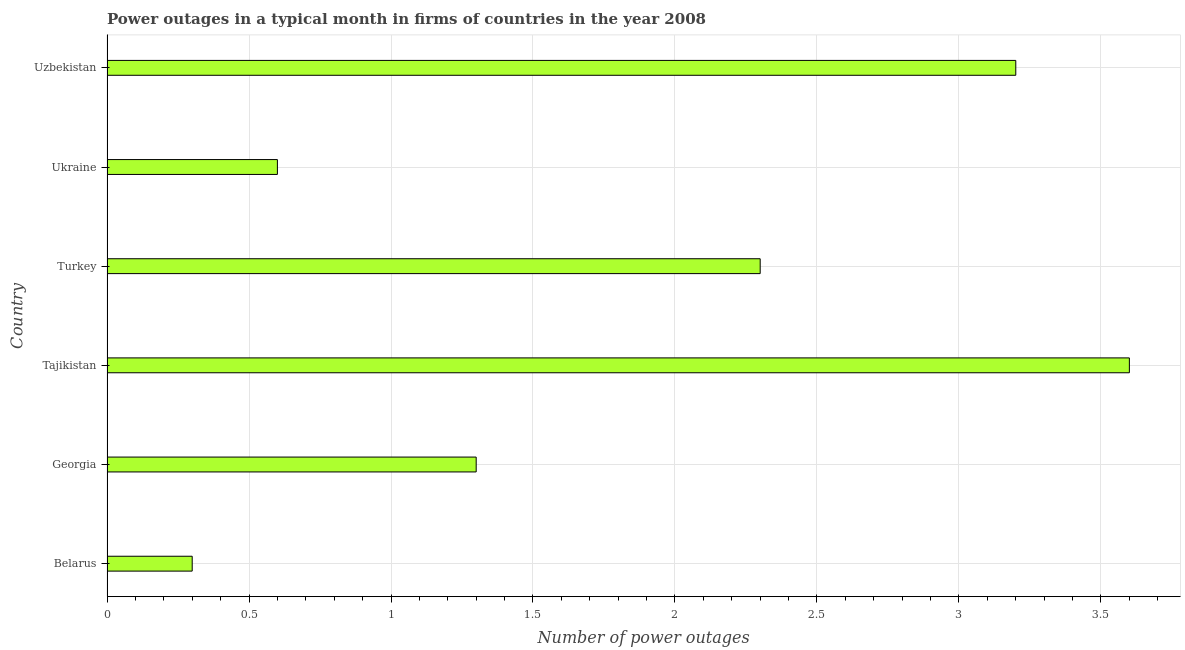Does the graph contain any zero values?
Make the answer very short. No. What is the title of the graph?
Your answer should be very brief. Power outages in a typical month in firms of countries in the year 2008. What is the label or title of the X-axis?
Offer a terse response. Number of power outages. Across all countries, what is the maximum number of power outages?
Provide a succinct answer. 3.6. In which country was the number of power outages maximum?
Make the answer very short. Tajikistan. In which country was the number of power outages minimum?
Provide a short and direct response. Belarus. What is the average number of power outages per country?
Offer a very short reply. 1.88. What is the median number of power outages?
Offer a terse response. 1.8. What is the ratio of the number of power outages in Turkey to that in Uzbekistan?
Your answer should be very brief. 0.72. Is the sum of the number of power outages in Georgia and Turkey greater than the maximum number of power outages across all countries?
Offer a terse response. No. In how many countries, is the number of power outages greater than the average number of power outages taken over all countries?
Give a very brief answer. 3. How many bars are there?
Your response must be concise. 6. Are the values on the major ticks of X-axis written in scientific E-notation?
Offer a very short reply. No. What is the Number of power outages of Turkey?
Make the answer very short. 2.3. What is the Number of power outages of Uzbekistan?
Give a very brief answer. 3.2. What is the difference between the Number of power outages in Belarus and Georgia?
Your answer should be compact. -1. What is the difference between the Number of power outages in Belarus and Uzbekistan?
Provide a short and direct response. -2.9. What is the difference between the Number of power outages in Georgia and Turkey?
Give a very brief answer. -1. What is the difference between the Number of power outages in Georgia and Uzbekistan?
Give a very brief answer. -1.9. What is the difference between the Number of power outages in Tajikistan and Ukraine?
Offer a terse response. 3. What is the difference between the Number of power outages in Turkey and Ukraine?
Provide a succinct answer. 1.7. What is the ratio of the Number of power outages in Belarus to that in Georgia?
Offer a terse response. 0.23. What is the ratio of the Number of power outages in Belarus to that in Tajikistan?
Make the answer very short. 0.08. What is the ratio of the Number of power outages in Belarus to that in Turkey?
Offer a very short reply. 0.13. What is the ratio of the Number of power outages in Belarus to that in Uzbekistan?
Provide a short and direct response. 0.09. What is the ratio of the Number of power outages in Georgia to that in Tajikistan?
Ensure brevity in your answer.  0.36. What is the ratio of the Number of power outages in Georgia to that in Turkey?
Provide a succinct answer. 0.56. What is the ratio of the Number of power outages in Georgia to that in Ukraine?
Make the answer very short. 2.17. What is the ratio of the Number of power outages in Georgia to that in Uzbekistan?
Keep it short and to the point. 0.41. What is the ratio of the Number of power outages in Tajikistan to that in Turkey?
Your response must be concise. 1.56. What is the ratio of the Number of power outages in Tajikistan to that in Ukraine?
Keep it short and to the point. 6. What is the ratio of the Number of power outages in Tajikistan to that in Uzbekistan?
Give a very brief answer. 1.12. What is the ratio of the Number of power outages in Turkey to that in Ukraine?
Give a very brief answer. 3.83. What is the ratio of the Number of power outages in Turkey to that in Uzbekistan?
Provide a short and direct response. 0.72. What is the ratio of the Number of power outages in Ukraine to that in Uzbekistan?
Keep it short and to the point. 0.19. 